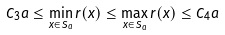Convert formula to latex. <formula><loc_0><loc_0><loc_500><loc_500>C _ { 3 } a \leq \min _ { x \in S _ { a } } r ( x ) \leq \max _ { x \in S _ { a } } r ( x ) \leq C _ { 4 } a</formula> 